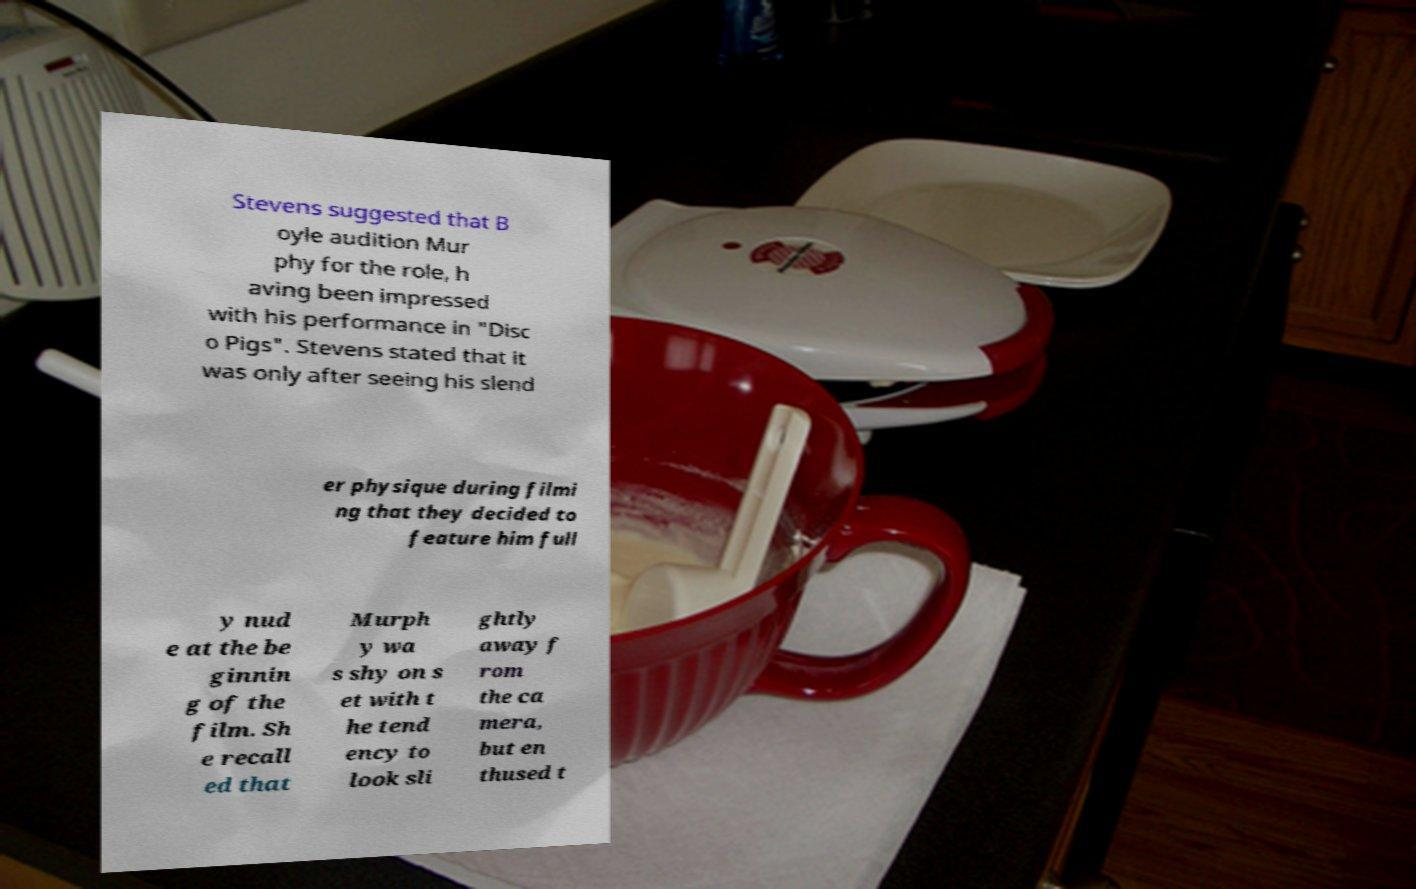Can you accurately transcribe the text from the provided image for me? Stevens suggested that B oyle audition Mur phy for the role, h aving been impressed with his performance in "Disc o Pigs". Stevens stated that it was only after seeing his slend er physique during filmi ng that they decided to feature him full y nud e at the be ginnin g of the film. Sh e recall ed that Murph y wa s shy on s et with t he tend ency to look sli ghtly away f rom the ca mera, but en thused t 